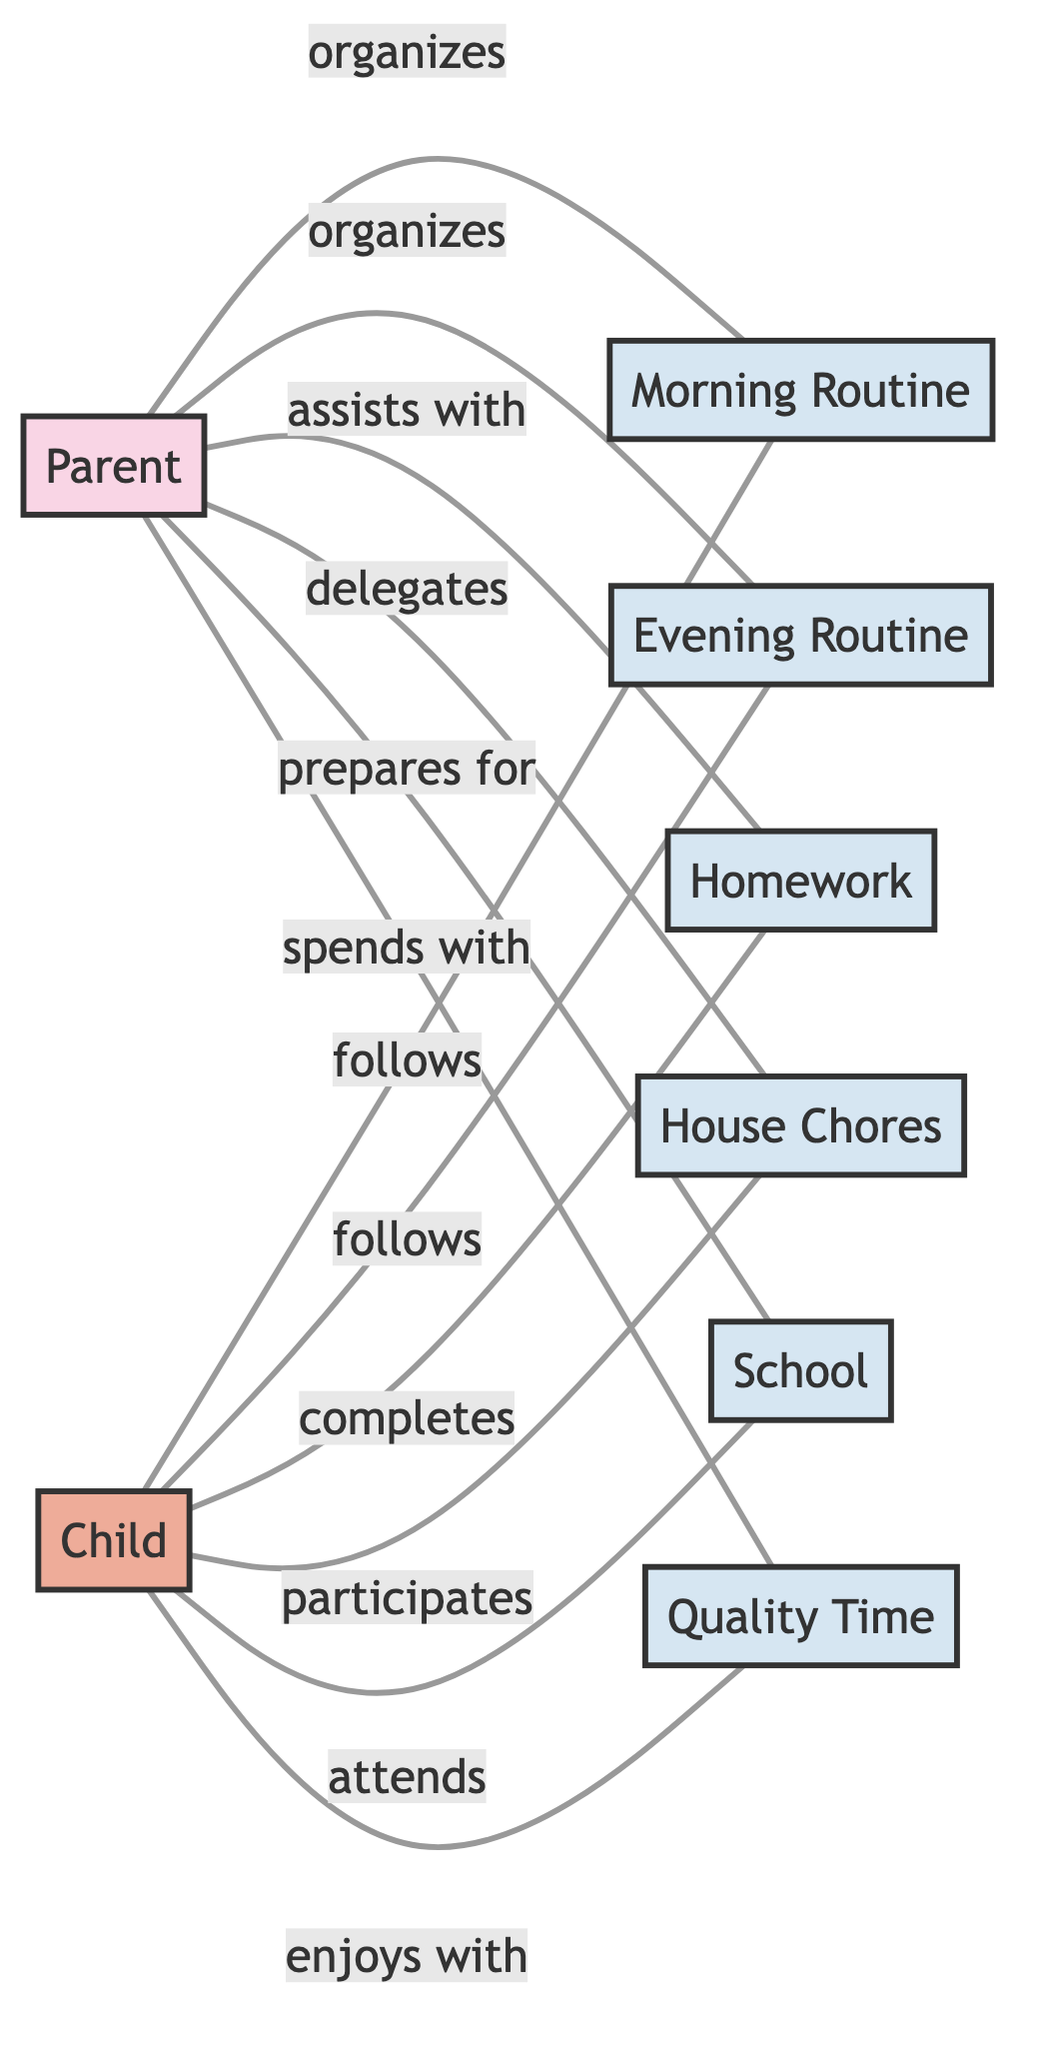What is the total number of nodes in the diagram? The nodes in the diagram represent entities: Parent, Child, Morning Routine, Evening Routine, Homework, House Chores, School, and Quality Time. Counting all these entities, we find a total of 8 nodes.
Answer: 8 Which node participates in House Chores? The edge connecting the Child node to House Chores shows that the Child participates in this activity, as indicated by the label "participates".
Answer: Child How many connections does the Parent node have? The Parent node has five edges connected to it: organizes Morning Routine, organizes Evening Routine, assists with Homework, delegates House Chores, and prepares for School. Counting these edges, the Parent node has 5 connections in total.
Answer: 5 Who completes Homework? The edge from the Child node to Homework indicates that the Child completes this activity, as indicated by the label "completes".
Answer: Child What is the relationship between Parent and Quality Time? The edge connecting Parent to Quality Time has the label "spends with", which indicates that the Parent spends time with the Child during this activity.
Answer: spends with Which two nodes have a direct relationship involving the Evening Routine? The Parent and Child nodes both have edges connecting to Evening Routine, where the Parent organizes it and the Child follows it. Therefore, the direct relationship involves the Parent and Child nodes.
Answer: Parent, Child Which activity does the Child attend? The edge from the Child node to School describes the relationship where the Child attends School, as indicated by the label "attends".
Answer: School What is the role of the Parent in Homework? The edge from the Parent node to Homework indicates that the Parent assists with this activity, as described by the label "assists with".
Answer: assists with What is the common activity both the Parent and Child enjoy together? The edges leading to Quality Time show that both the Parent spends time and the Child enjoys time with the Parent, indicating this common activity of Quality Time.
Answer: Quality Time 